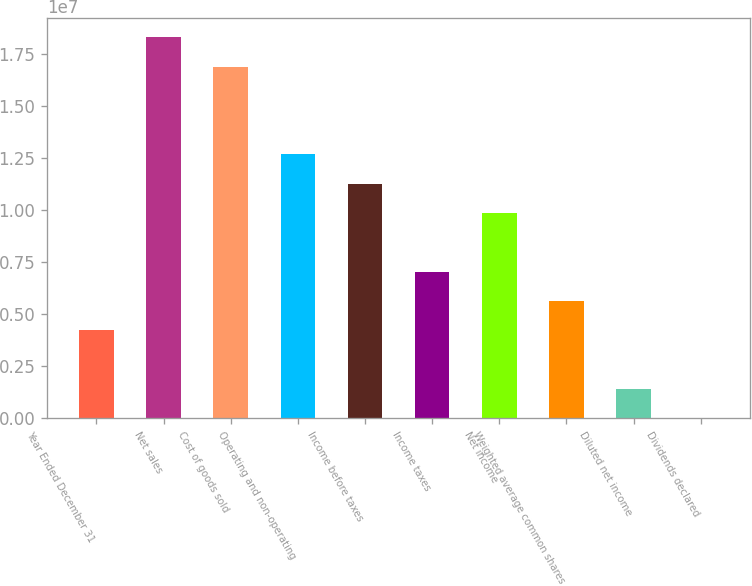Convert chart. <chart><loc_0><loc_0><loc_500><loc_500><bar_chart><fcel>Year Ended December 31<fcel>Net sales<fcel>Cost of goods sold<fcel>Operating and non-operating<fcel>Income before taxes<fcel>Income taxes<fcel>Net income<fcel>Weighted average common shares<fcel>Diluted net income<fcel>Dividends declared<nl><fcel>4.22335e+06<fcel>1.83012e+07<fcel>1.68934e+07<fcel>1.26701e+07<fcel>1.12623e+07<fcel>7.03892e+06<fcel>9.85449e+06<fcel>5.63114e+06<fcel>1.40779e+06<fcel>2.15<nl></chart> 